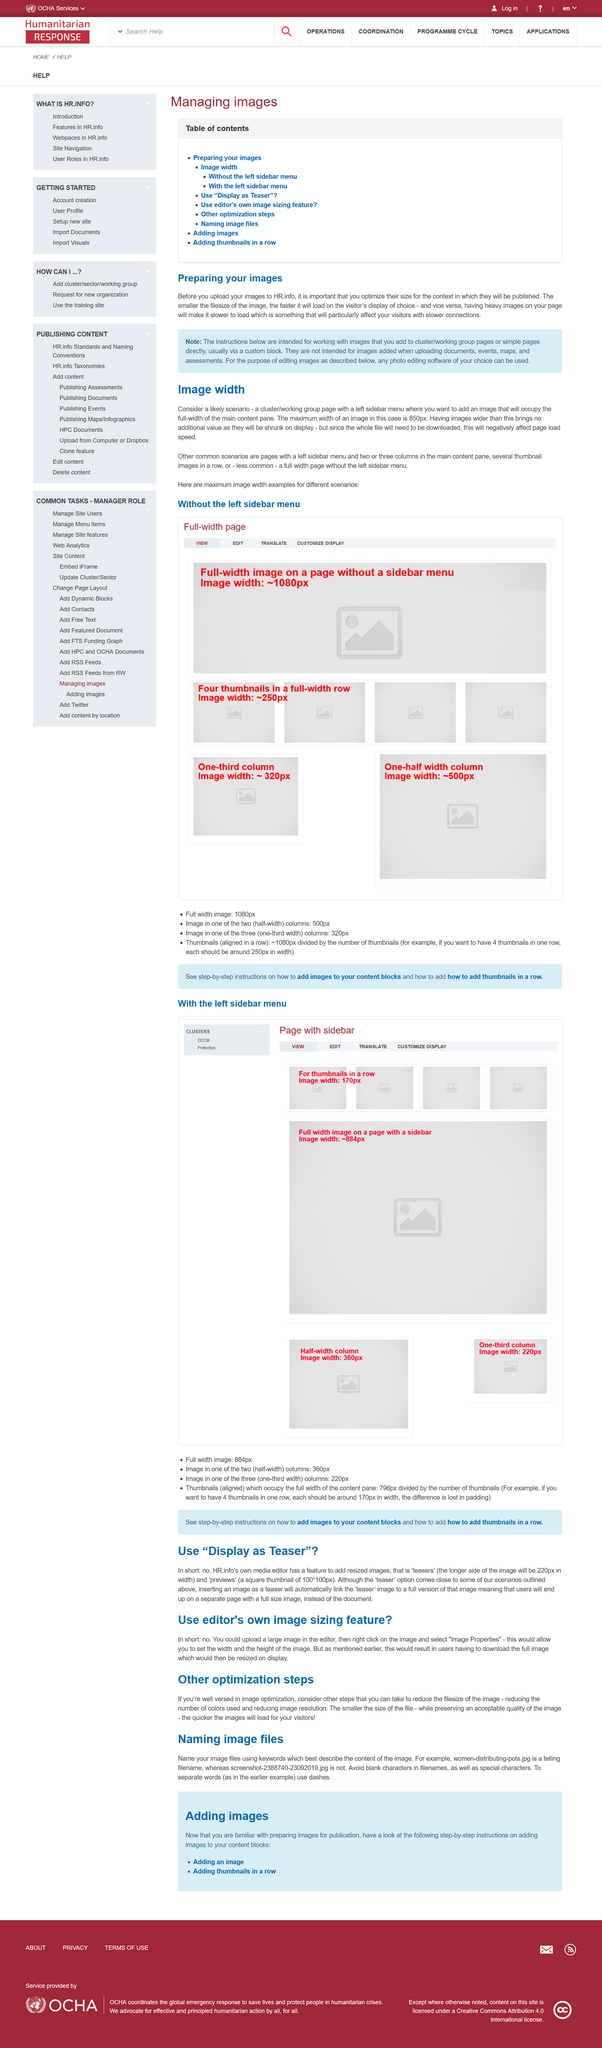Draw attention to some important aspects in this diagram. Smaller file size will result in faster image load time. Yes, having heavy images on a page can make it slower to load. Optimizing an image's size before uploading it is a crucial element of preparing images. 